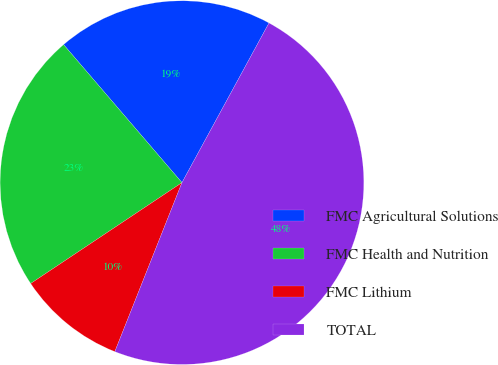Convert chart. <chart><loc_0><loc_0><loc_500><loc_500><pie_chart><fcel>FMC Agricultural Solutions<fcel>FMC Health and Nutrition<fcel>FMC Lithium<fcel>TOTAL<nl><fcel>19.23%<fcel>23.08%<fcel>9.62%<fcel>48.08%<nl></chart> 